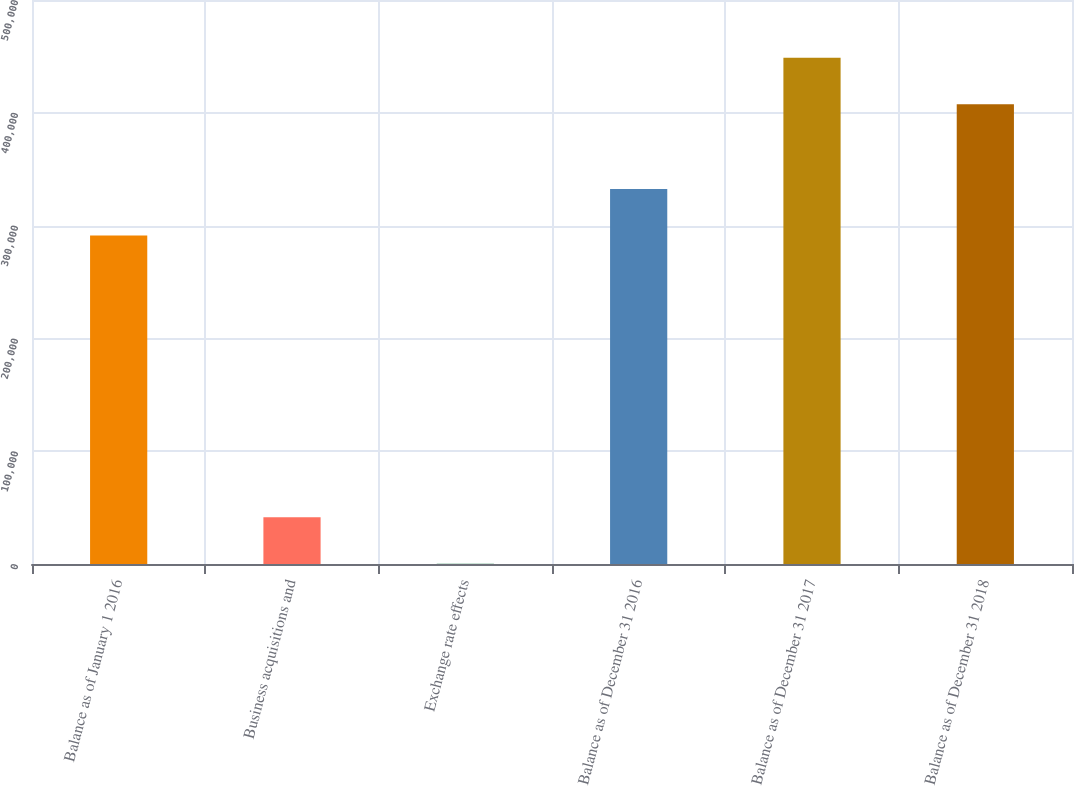<chart> <loc_0><loc_0><loc_500><loc_500><bar_chart><fcel>Balance as of January 1 2016<fcel>Business acquisitions and<fcel>Exchange rate effects<fcel>Balance as of December 31 2016<fcel>Balance as of December 31 2017<fcel>Balance as of December 31 2018<nl><fcel>291265<fcel>41370.8<fcel>161<fcel>332475<fcel>448847<fcel>407637<nl></chart> 